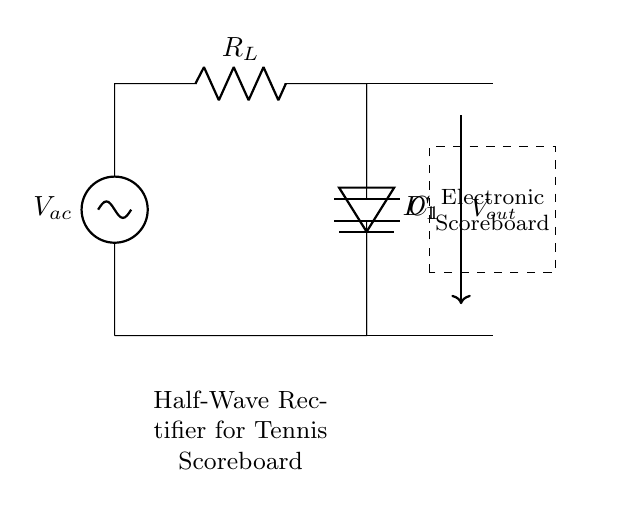What type of rectifier is shown in this circuit? The diagram depicts a half-wave rectifier, characterized by the presence of a single diode that allows current through only during one half of the AC cycle.
Answer: Half-wave rectifier What component is labeled as R_L? R_L represents the load resistor in the circuit, which is where the rectified voltage is applied for powering the electronic scoreboard.
Answer: Load resistor How many diodes are present in this circuit? There is only one diode indicated (D_1), which is typical for a half-wave rectifier to provide unidirectional current flow.
Answer: One What is the purpose of component C_1? C_1 is a capacitor that serves to smooth the output voltage by reducing the ripple in the rectified signal, improving the voltage stability for the scoreboard.
Answer: Smoothing What does V_out represent in this circuit? V_out indicates the output voltage across the load resistor R_L, which is the rectified DC voltage available for the electronic scoreboard.
Answer: Output voltage What would happen if the diode was removed? If the diode were removed, the circuit would effectively become shorted, allowing current to flow in both directions and failing to rectify the AC voltage for the scoreboard.
Answer: No rectification 